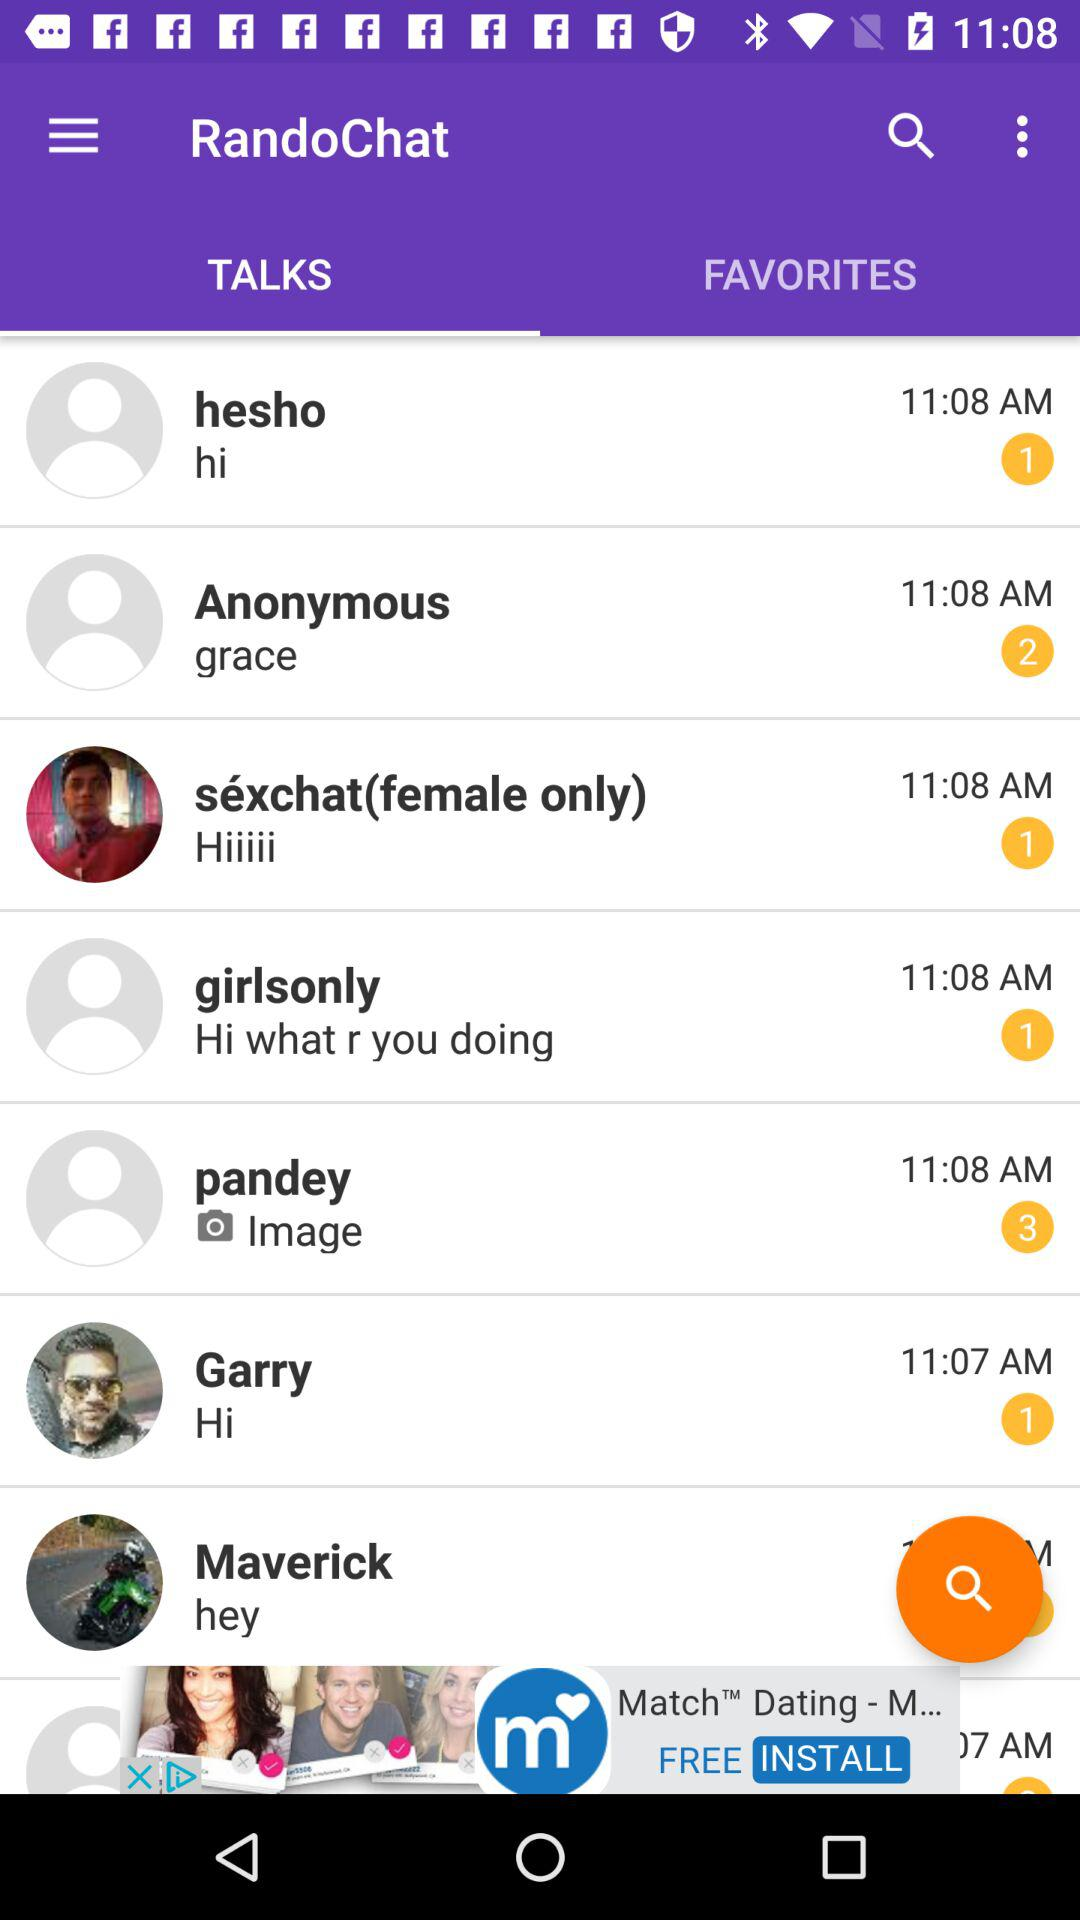What message is received from "Anonymous"? The message that is received from "Anonymous" is "grace". 